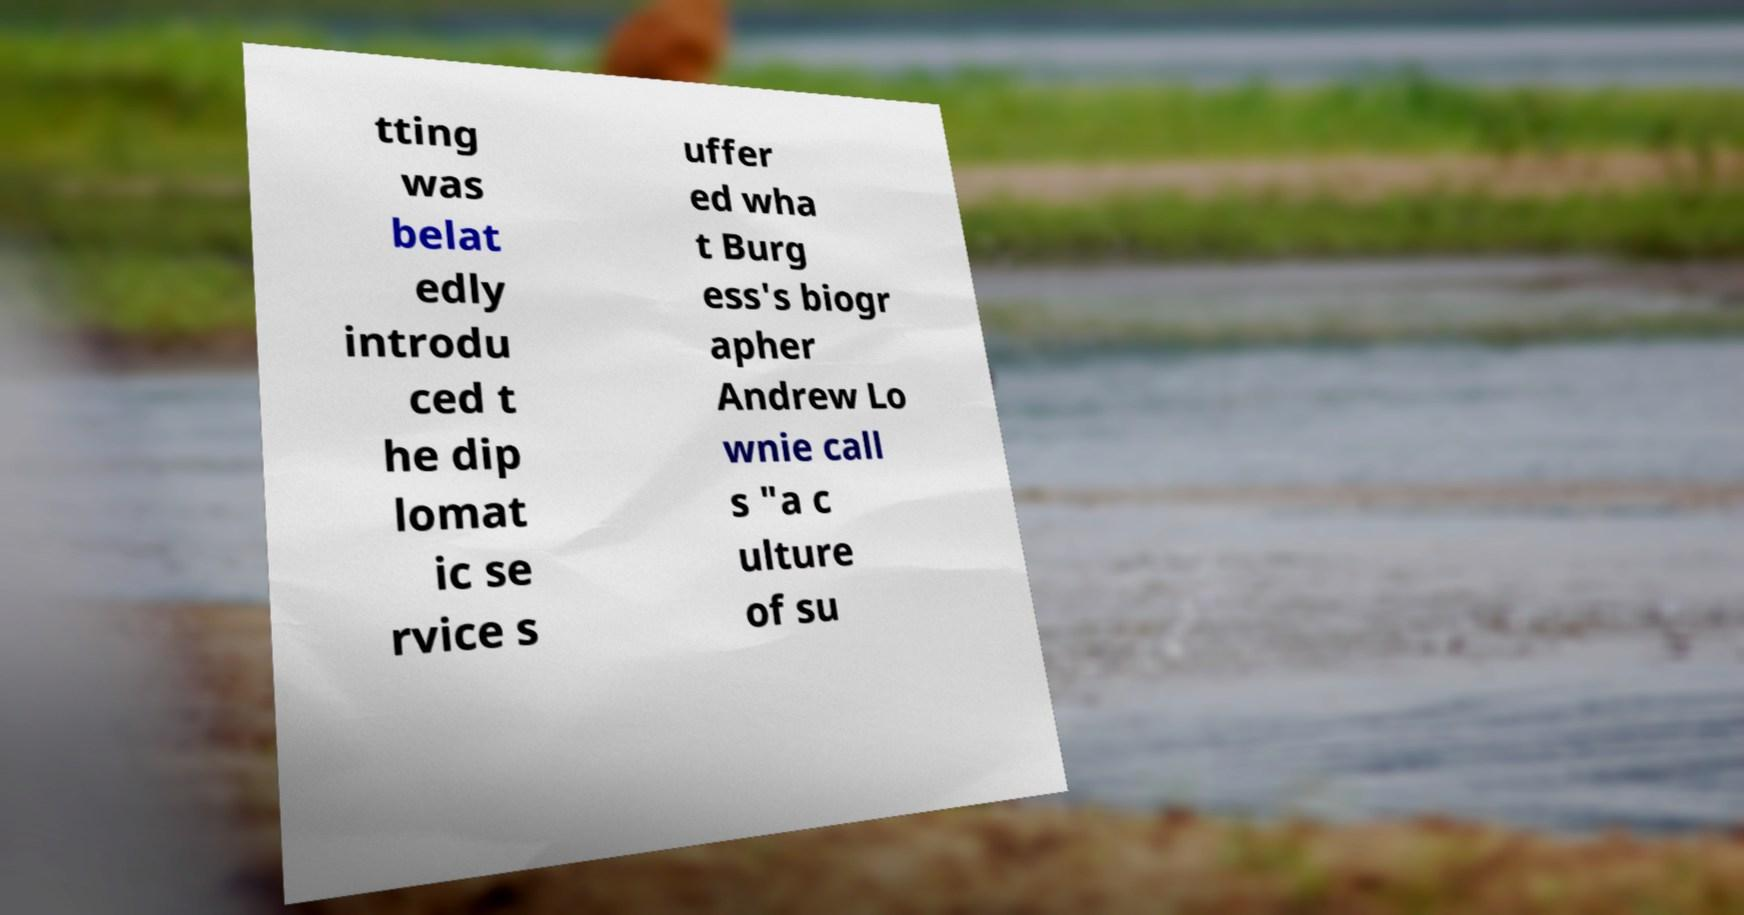Can you read and provide the text displayed in the image?This photo seems to have some interesting text. Can you extract and type it out for me? tting was belat edly introdu ced t he dip lomat ic se rvice s uffer ed wha t Burg ess's biogr apher Andrew Lo wnie call s "a c ulture of su 